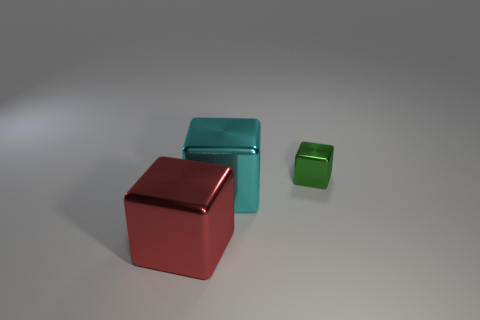Subtract all big blocks. How many blocks are left? 1 Add 2 large brown rubber blocks. How many objects exist? 5 Subtract all red blocks. How many blocks are left? 2 Subtract 1 blocks. How many blocks are left? 2 Subtract all cyan metallic blocks. Subtract all red metal objects. How many objects are left? 1 Add 3 large things. How many large things are left? 5 Add 1 metal things. How many metal things exist? 4 Subtract 0 green balls. How many objects are left? 3 Subtract all blue blocks. Subtract all purple balls. How many blocks are left? 3 